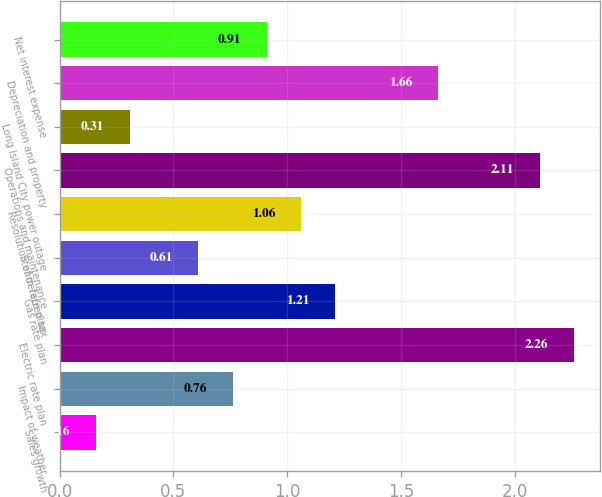Convert chart. <chart><loc_0><loc_0><loc_500><loc_500><bar_chart><fcel>Sales growth<fcel>Impact of weather<fcel>Electric rate plan<fcel>Gas rate plan<fcel>Steam rate plan<fcel>Resolution of deferred tax<fcel>Operations and maintenance<fcel>Long Island City power outage<fcel>Depreciation and property<fcel>Net interest expense<nl><fcel>0.16<fcel>0.76<fcel>2.26<fcel>1.21<fcel>0.61<fcel>1.06<fcel>2.11<fcel>0.31<fcel>1.66<fcel>0.91<nl></chart> 